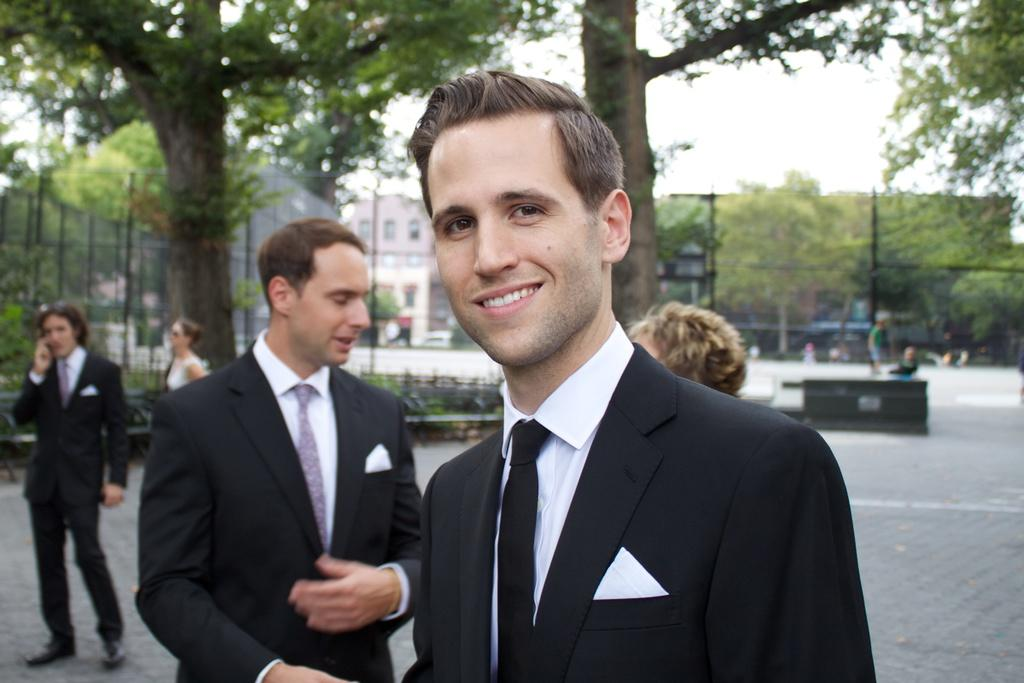What is the main subject of the image? There is a man standing in the center of the image. What is the man's facial expression? The man is smiling. What is the man wearing? The man is wearing a suit. What can be seen in the background of the image? There are people, trees, a fence, a building, and the sky visible in the background of the image. What month is the man planning his voyage to in the image? There is no mention of a voyage or a specific month in the image. 